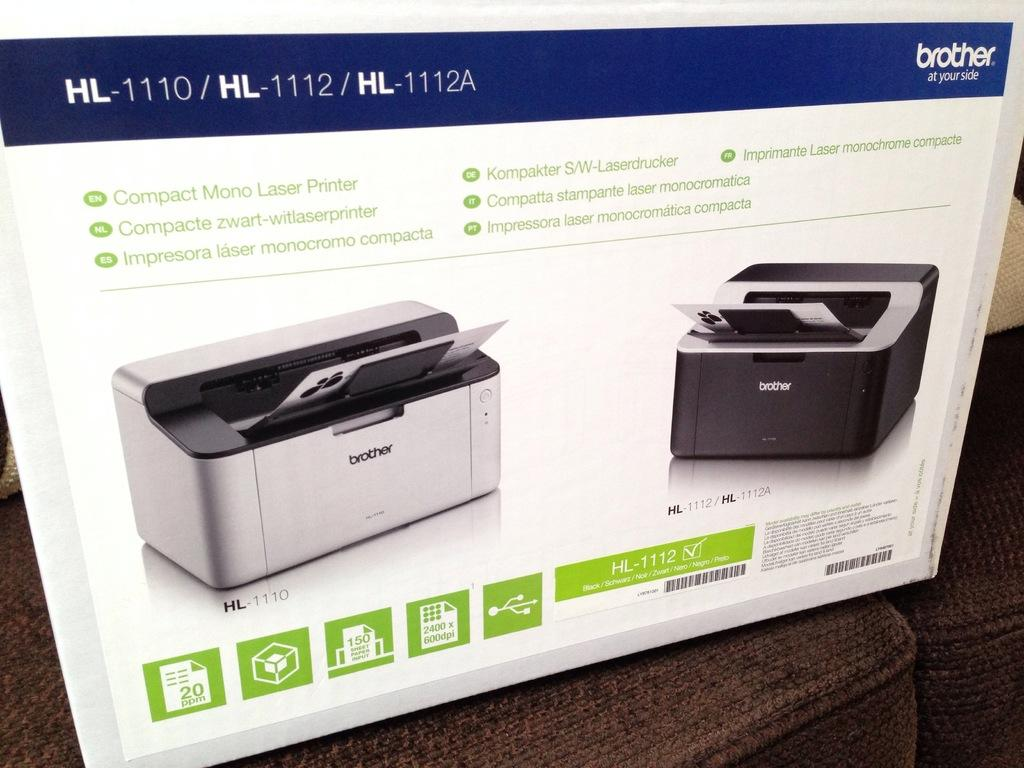<image>
Provide a brief description of the given image. The Brother HL-1110 is a Mono Laser Printer, not a color printer. 